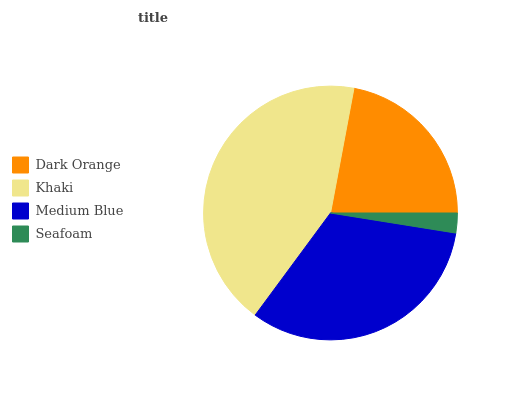Is Seafoam the minimum?
Answer yes or no. Yes. Is Khaki the maximum?
Answer yes or no. Yes. Is Medium Blue the minimum?
Answer yes or no. No. Is Medium Blue the maximum?
Answer yes or no. No. Is Khaki greater than Medium Blue?
Answer yes or no. Yes. Is Medium Blue less than Khaki?
Answer yes or no. Yes. Is Medium Blue greater than Khaki?
Answer yes or no. No. Is Khaki less than Medium Blue?
Answer yes or no. No. Is Medium Blue the high median?
Answer yes or no. Yes. Is Dark Orange the low median?
Answer yes or no. Yes. Is Dark Orange the high median?
Answer yes or no. No. Is Khaki the low median?
Answer yes or no. No. 